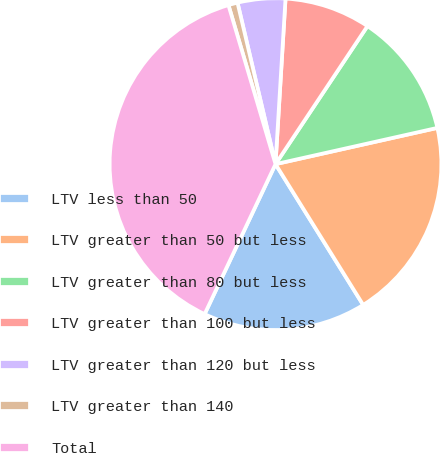<chart> <loc_0><loc_0><loc_500><loc_500><pie_chart><fcel>LTV less than 50<fcel>LTV greater than 50 but less<fcel>LTV greater than 80 but less<fcel>LTV greater than 100 but less<fcel>LTV greater than 120 but less<fcel>LTV greater than 140<fcel>Total<nl><fcel>15.89%<fcel>19.64%<fcel>12.14%<fcel>8.39%<fcel>4.64%<fcel>0.9%<fcel>38.39%<nl></chart> 